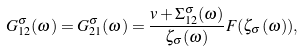<formula> <loc_0><loc_0><loc_500><loc_500>G ^ { \sigma } _ { 1 2 } ( \omega ) = G ^ { \sigma } _ { 2 1 } ( \omega ) = \frac { v + \Sigma ^ { \sigma } _ { 1 2 } ( \omega ) } { \zeta _ { \sigma } ( \omega ) } F ( \zeta _ { \sigma } ( \omega ) ) ,</formula> 